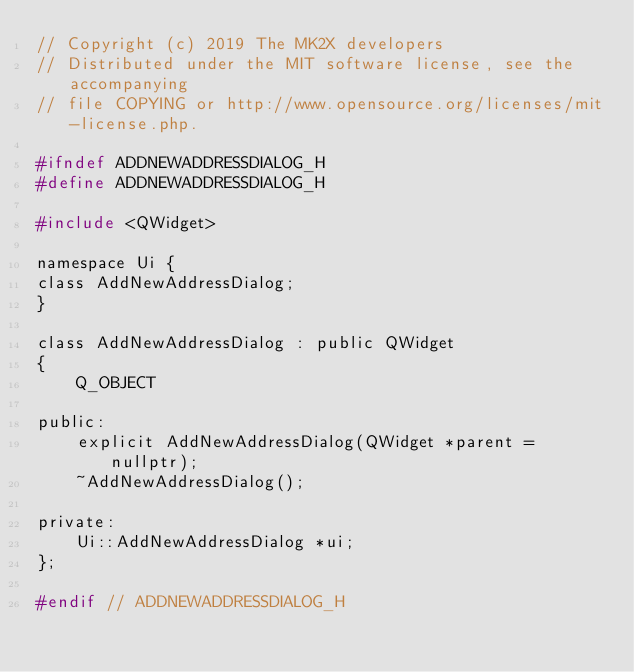<code> <loc_0><loc_0><loc_500><loc_500><_C_>// Copyright (c) 2019 The MK2X developers
// Distributed under the MIT software license, see the accompanying
// file COPYING or http://www.opensource.org/licenses/mit-license.php.

#ifndef ADDNEWADDRESSDIALOG_H
#define ADDNEWADDRESSDIALOG_H

#include <QWidget>

namespace Ui {
class AddNewAddressDialog;
}

class AddNewAddressDialog : public QWidget
{
    Q_OBJECT

public:
    explicit AddNewAddressDialog(QWidget *parent = nullptr);
    ~AddNewAddressDialog();

private:
    Ui::AddNewAddressDialog *ui;
};

#endif // ADDNEWADDRESSDIALOG_H
</code> 